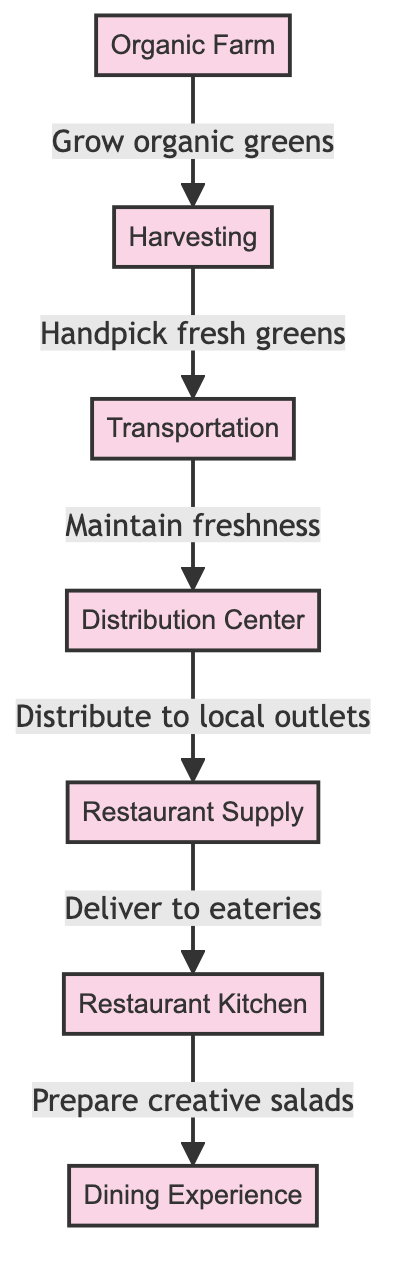What is the starting point of the food chain? The food chain begins at the "Organic Farm," which is the first node in the diagram.
Answer: Organic Farm How many steps are there in the food chain from farm to table? There are six distinct steps in the food chain as represented by the six nodes in the diagram: Organic Farm, Harvesting, Transportation, Distribution Center, Restaurant Supply, and Restaurant Kitchen.
Answer: Six What is done after harvesting? After harvesting, the next step is "Transportation" where the fresh greens are maintained for freshness before reaching the next stage.
Answer: Transportation What is the relationship between the Distribution Center and Restaurant Supply? The "Distribution Center" serves to distribute the products to local outlets, including the "Restaurant Supply," which is the next step in the food chain.
Answer: Distribute to local outlets What is the final step in the food chain? The final step in the food chain is the "Dining Experience," which represents the moment when diners enjoy their salads.
Answer: Dining Experience What process occurs at the Restaurant Kitchen? In the Restaurant Kitchen, the fresh greens are prepared into creative salads, which is a crucial step before serving to the diners.
Answer: Prepare creative salads What is the purpose of maintaining freshness during transportation? Maintaining freshness during transportation ensures that the greens arrive in optimal condition, ready for further processing in the restaurant.
Answer: Maintain freshness Which step involves handpicking? "Harvesting" is the step where fresh greens are handpicked from the farm, highlighting the care taken in the organic farming process.
Answer: Handpick fresh greens How are the products delivered to eateries? The flow indicates that after distribution, the products are delivered through the "Restaurant Supply" to the "Restaurant Kitchen," facilitating the preparation of meals.
Answer: Deliver to eateries 